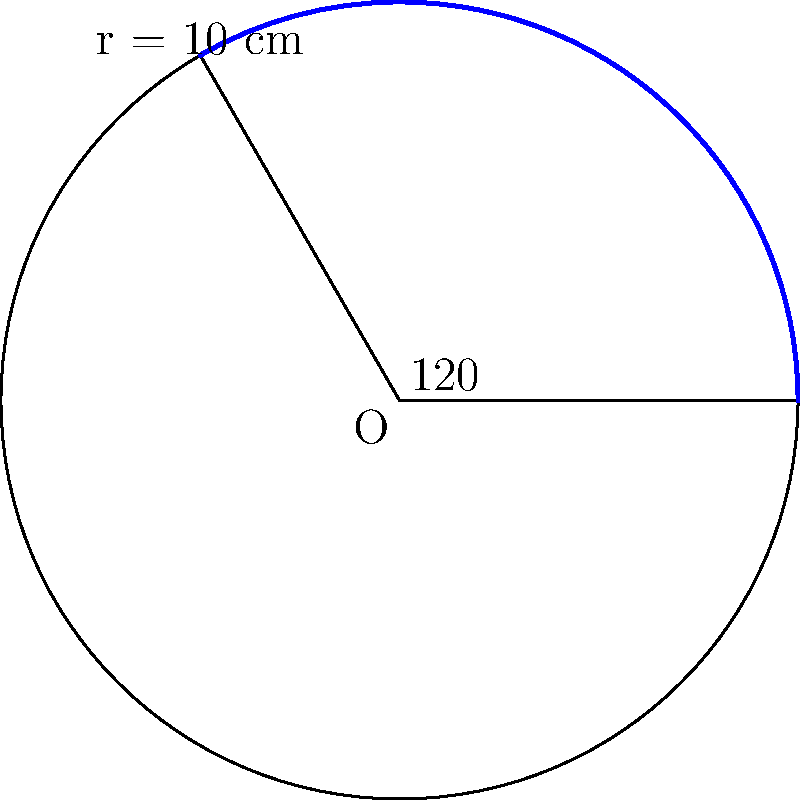A circular tablet dispenser for medication distribution needs to be designed for ease of use. The dispenser has a radius of 10 cm and a central angle of 120°. Calculate the area of the sector that will hold a specific medication. Round your answer to the nearest square centimeter. To calculate the area of a circular sector, we follow these steps:

1) The formula for the area of a circular sector is:
   $$A = \frac{\theta}{360°} \pi r^2$$
   where $\theta$ is the central angle in degrees, and $r$ is the radius.

2) We are given:
   $\theta = 120°$
   $r = 10$ cm

3) Substituting these values into the formula:
   $$A = \frac{120°}{360°} \pi (10\text{ cm})^2$$

4) Simplify:
   $$A = \frac{1}{3} \pi (100\text{ cm}^2)$$

5) Calculate:
   $$A = \frac{1}{3} \times 3.14159... \times 100\text{ cm}^2$$
   $$A \approx 104.72\text{ cm}^2$$

6) Rounding to the nearest square centimeter:
   $$A \approx 105\text{ cm}^2$$
Answer: 105 cm² 